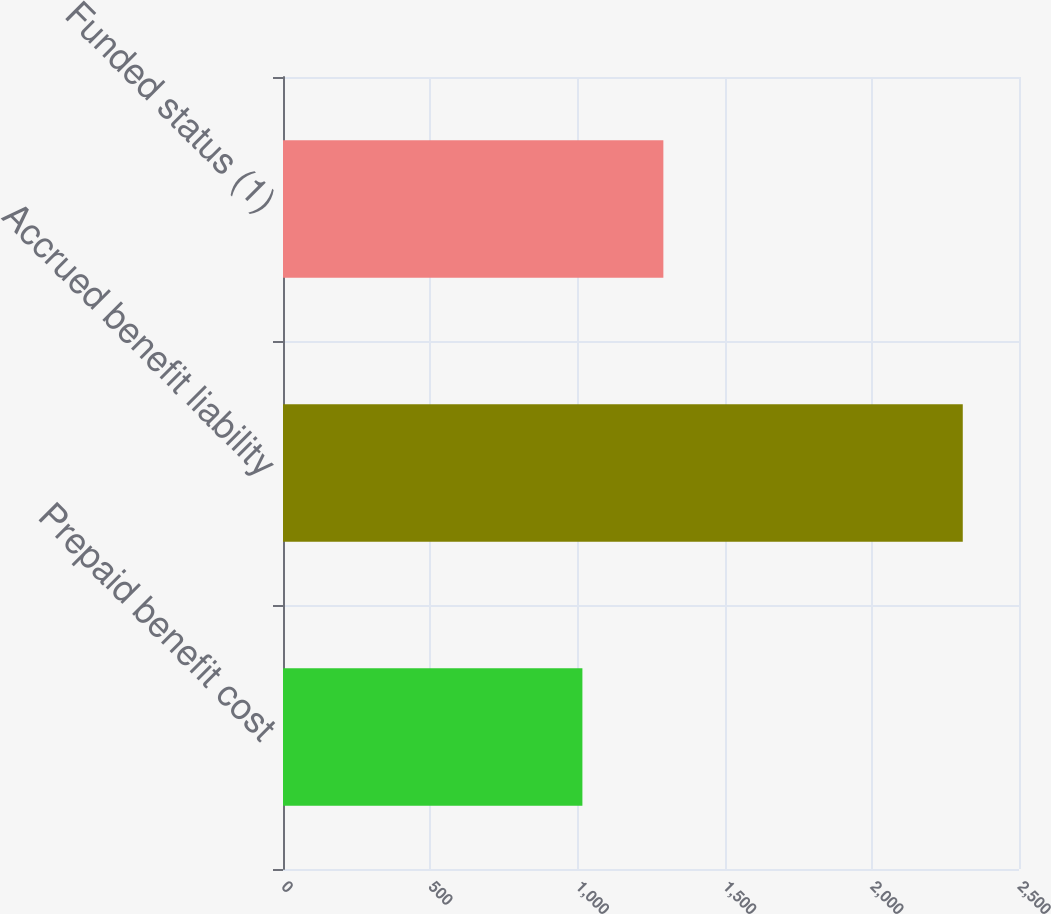Convert chart. <chart><loc_0><loc_0><loc_500><loc_500><bar_chart><fcel>Prepaid benefit cost<fcel>Accrued benefit liability<fcel>Funded status (1)<nl><fcel>1017<fcel>2309<fcel>1292<nl></chart> 